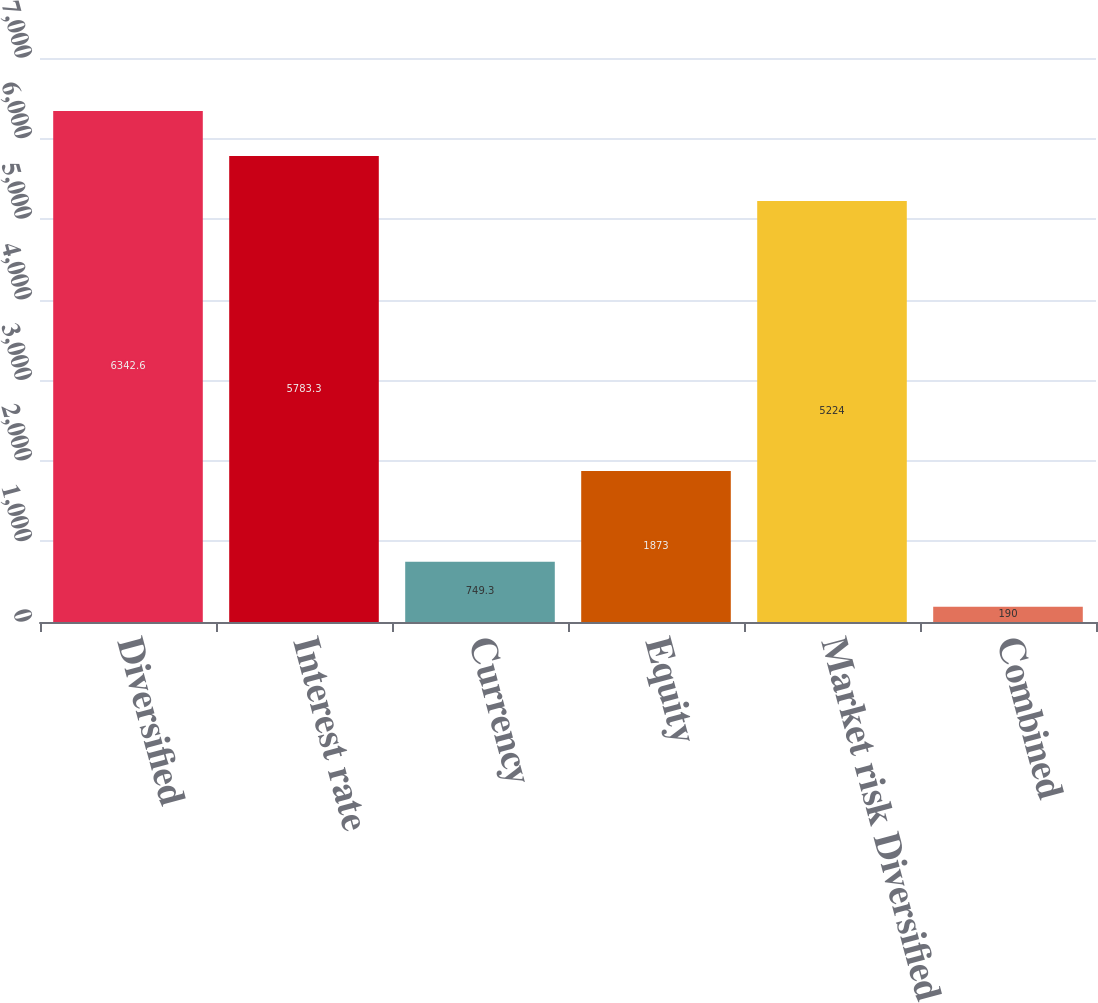Convert chart. <chart><loc_0><loc_0><loc_500><loc_500><bar_chart><fcel>Diversified<fcel>Interest rate<fcel>Currency<fcel>Equity<fcel>Market risk Diversified<fcel>Combined<nl><fcel>6342.6<fcel>5783.3<fcel>749.3<fcel>1873<fcel>5224<fcel>190<nl></chart> 